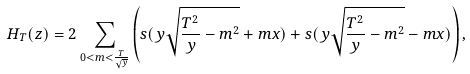<formula> <loc_0><loc_0><loc_500><loc_500>H _ { T } ( z ) = 2 \sum _ { 0 < m < \frac { T } { \sqrt { y } } } \left ( s ( y \sqrt { \frac { T ^ { 2 } } { y } - m ^ { 2 } } + m x ) + s ( y \sqrt { \frac { T ^ { 2 } } { y } - m ^ { 2 } } - m x ) \right ) ,</formula> 